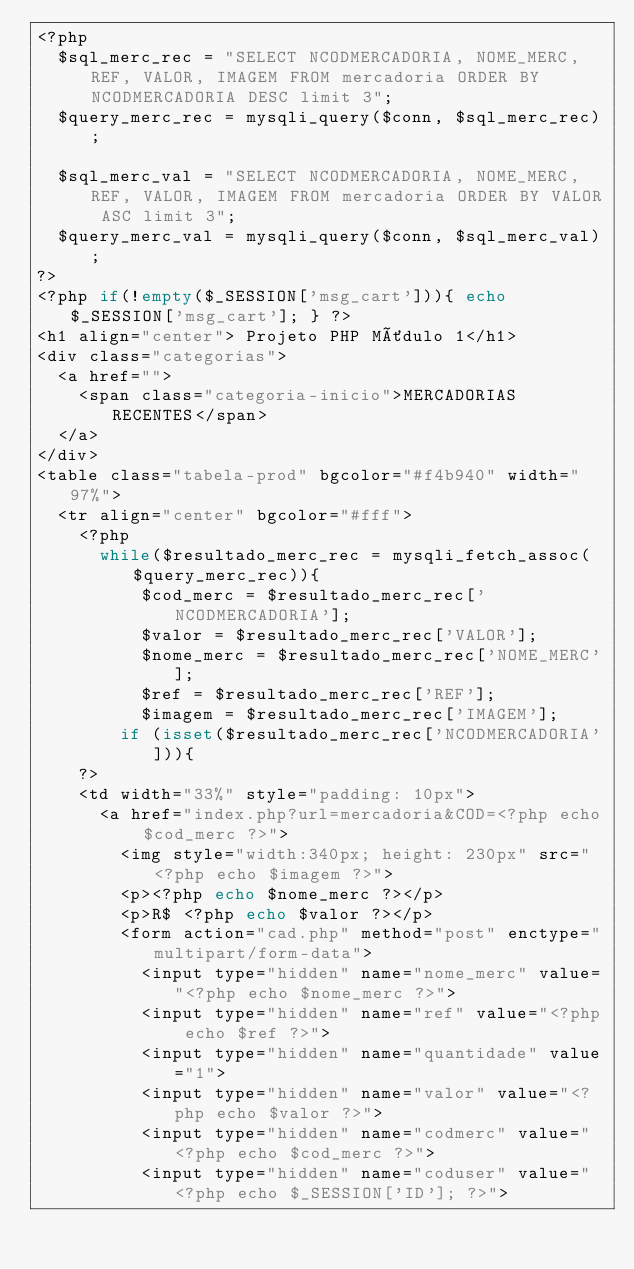Convert code to text. <code><loc_0><loc_0><loc_500><loc_500><_PHP_><?php
	$sql_merc_rec = "SELECT NCODMERCADORIA, NOME_MERC, REF, VALOR, IMAGEM FROM mercadoria ORDER BY NCODMERCADORIA DESC limit 3";
	$query_merc_rec = mysqli_query($conn, $sql_merc_rec);

	$sql_merc_val = "SELECT NCODMERCADORIA, NOME_MERC, REF, VALOR, IMAGEM FROM mercadoria ORDER BY VALOR ASC limit 3";
	$query_merc_val = mysqli_query($conn, $sql_merc_val);
?>
<?php if(!empty($_SESSION['msg_cart'])){ echo $_SESSION['msg_cart']; } ?>
<h1 align="center"> Projeto PHP Môdulo 1</h1>
<div class="categorias">
	<a href="">
		<span class="categoria-inicio">MERCADORIAS RECENTES</span>
	</a>
</div>
<table class="tabela-prod" bgcolor="#f4b940" width="97%">
	<tr align="center" bgcolor="#fff">
		<?php
			while($resultado_merc_rec = mysqli_fetch_assoc($query_merc_rec)){
					$cod_merc = $resultado_merc_rec['NCODMERCADORIA'];
					$valor = $resultado_merc_rec['VALOR'];
					$nome_merc = $resultado_merc_rec['NOME_MERC'];
					$ref = $resultado_merc_rec['REF'];
					$imagem = $resultado_merc_rec['IMAGEM'];
				if (isset($resultado_merc_rec['NCODMERCADORIA'])){
		?>
		<td width="33%" style="padding: 10px"> 
			<a href="index.php?url=mercadoria&COD=<?php echo $cod_merc ?>">
				<img style="width:340px; height: 230px" src="<?php echo $imagem ?>"> 
				<p><?php echo $nome_merc ?></p>
				<p>R$ <?php echo $valor ?></p>
				<form action="cad.php" method="post" enctype="multipart/form-data">
					<input type="hidden" name="nome_merc" value="<?php echo $nome_merc ?>">
					<input type="hidden" name="ref" value="<?php echo $ref ?>">
					<input type="hidden" name="quantidade" value="1">
					<input type="hidden" name="valor" value="<?php echo $valor ?>">
					<input type="hidden" name="codmerc" value="<?php echo $cod_merc ?>">
					<input type="hidden" name="coduser" value="<?php echo $_SESSION['ID']; ?>"></code> 